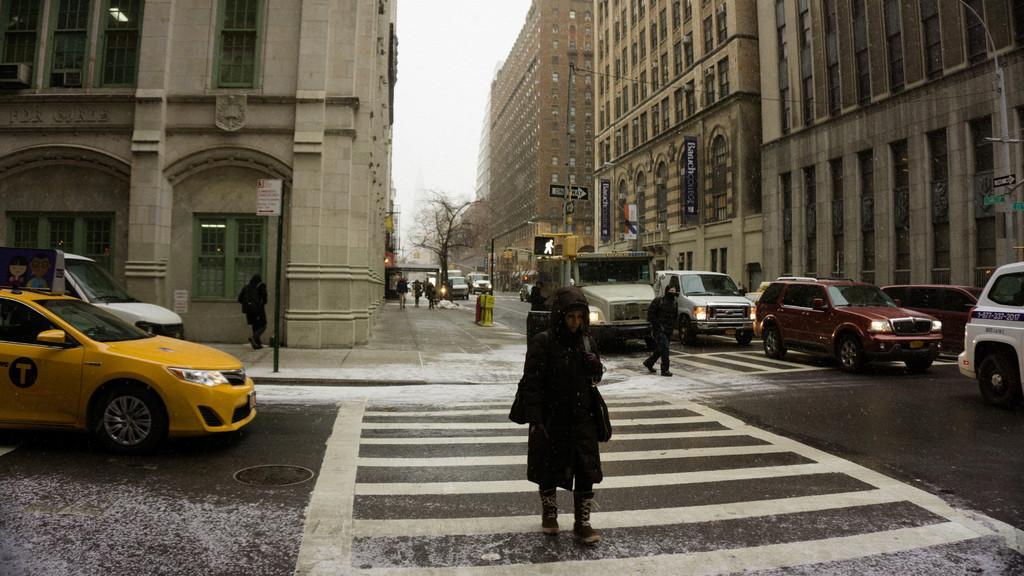How would you summarize this image in a sentence or two? As we can see in the image there are buildings, few people here and there, cars and tree. On the top there is a sky. 